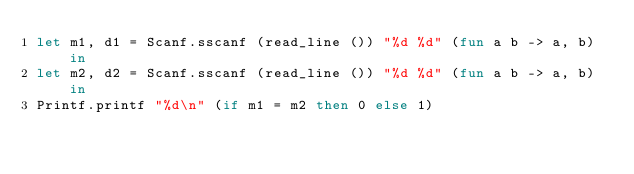Convert code to text. <code><loc_0><loc_0><loc_500><loc_500><_OCaml_>let m1, d1 = Scanf.sscanf (read_line ()) "%d %d" (fun a b -> a, b) in
let m2, d2 = Scanf.sscanf (read_line ()) "%d %d" (fun a b -> a, b) in
Printf.printf "%d\n" (if m1 = m2 then 0 else 1)</code> 